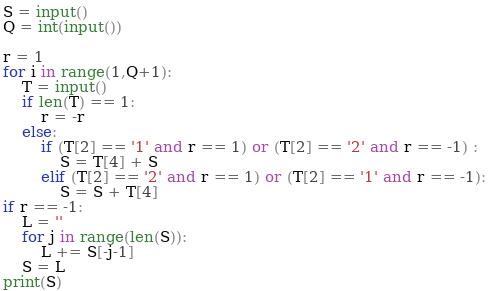<code> <loc_0><loc_0><loc_500><loc_500><_Python_>S = input()
Q = int(input())

r = 1
for i in range(1,Q+1):
    T = input()
    if len(T) == 1:
        r = -r
    else:
        if (T[2] == '1' and r == 1) or (T[2] == '2' and r == -1) :
            S = T[4] + S
        elif (T[2] == '2' and r == 1) or (T[2] == '1' and r == -1):
            S = S + T[4]
if r == -1:
    L = ''
    for j in range(len(S)):
        L += S[-j-1]
    S = L
print(S)</code> 